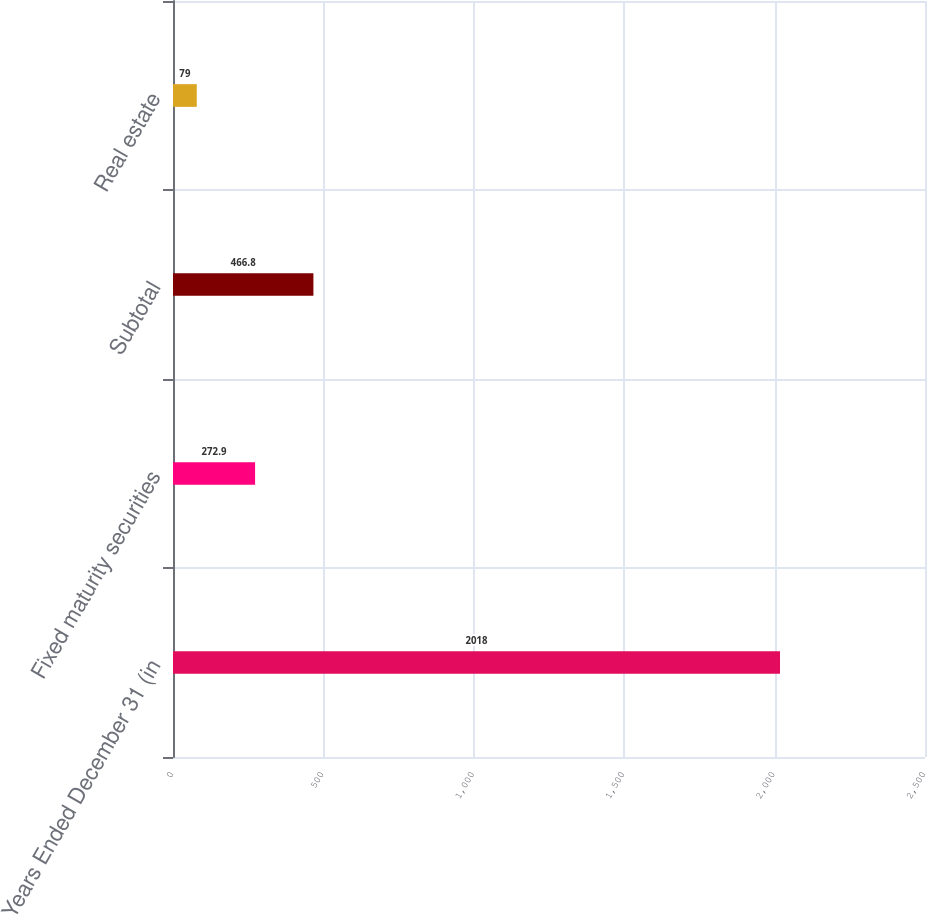<chart> <loc_0><loc_0><loc_500><loc_500><bar_chart><fcel>Years Ended December 31 (in<fcel>Fixed maturity securities<fcel>Subtotal<fcel>Real estate<nl><fcel>2018<fcel>272.9<fcel>466.8<fcel>79<nl></chart> 